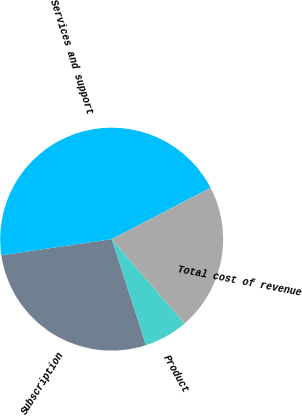Convert chart. <chart><loc_0><loc_0><loc_500><loc_500><pie_chart><fcel>Product<fcel>Subscription<fcel>Services and support<fcel>Total cost of revenue<nl><fcel>6.38%<fcel>27.66%<fcel>44.68%<fcel>21.28%<nl></chart> 